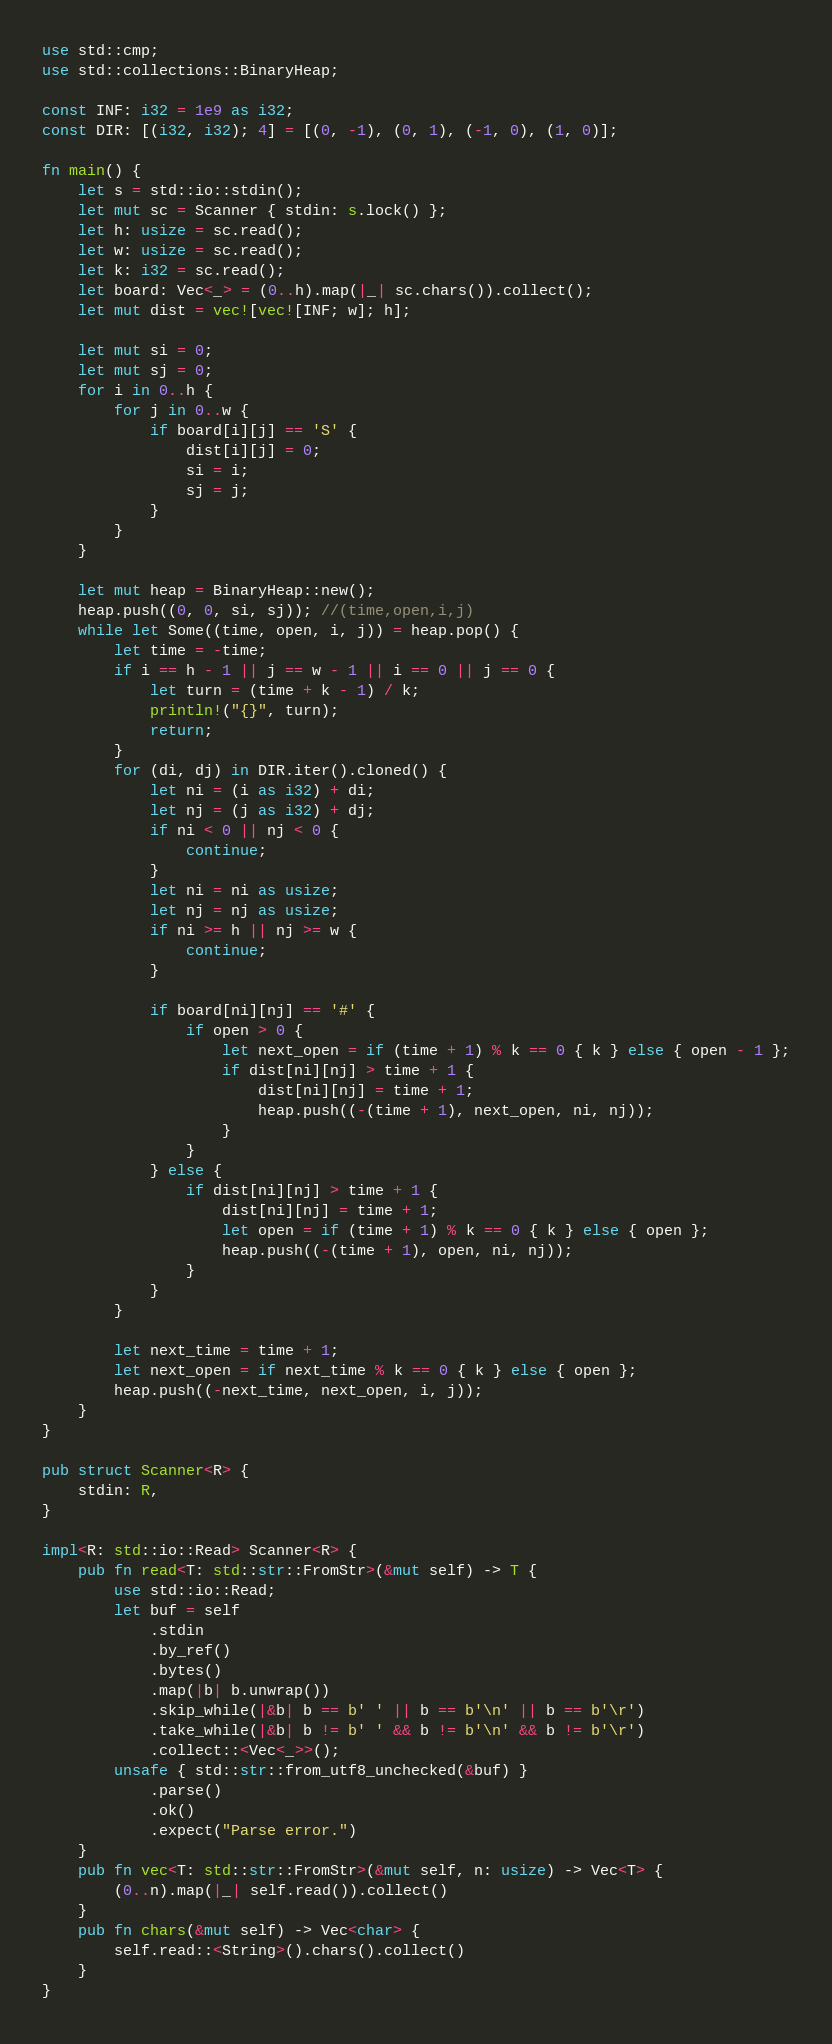Convert code to text. <code><loc_0><loc_0><loc_500><loc_500><_Rust_>use std::cmp;
use std::collections::BinaryHeap;

const INF: i32 = 1e9 as i32;
const DIR: [(i32, i32); 4] = [(0, -1), (0, 1), (-1, 0), (1, 0)];

fn main() {
    let s = std::io::stdin();
    let mut sc = Scanner { stdin: s.lock() };
    let h: usize = sc.read();
    let w: usize = sc.read();
    let k: i32 = sc.read();
    let board: Vec<_> = (0..h).map(|_| sc.chars()).collect();
    let mut dist = vec![vec![INF; w]; h];

    let mut si = 0;
    let mut sj = 0;
    for i in 0..h {
        for j in 0..w {
            if board[i][j] == 'S' {
                dist[i][j] = 0;
                si = i;
                sj = j;
            }
        }
    }

    let mut heap = BinaryHeap::new();
    heap.push((0, 0, si, sj)); //(time,open,i,j)
    while let Some((time, open, i, j)) = heap.pop() {
        let time = -time;
        if i == h - 1 || j == w - 1 || i == 0 || j == 0 {
            let turn = (time + k - 1) / k;
            println!("{}", turn);
            return;
        }
        for (di, dj) in DIR.iter().cloned() {
            let ni = (i as i32) + di;
            let nj = (j as i32) + dj;
            if ni < 0 || nj < 0 {
                continue;
            }
            let ni = ni as usize;
            let nj = nj as usize;
            if ni >= h || nj >= w {
                continue;
            }

            if board[ni][nj] == '#' {
                if open > 0 {
                    let next_open = if (time + 1) % k == 0 { k } else { open - 1 };
                    if dist[ni][nj] > time + 1 {
                        dist[ni][nj] = time + 1;
                        heap.push((-(time + 1), next_open, ni, nj));
                    }
                }
            } else {
                if dist[ni][nj] > time + 1 {
                    dist[ni][nj] = time + 1;
                    let open = if (time + 1) % k == 0 { k } else { open };
                    heap.push((-(time + 1), open, ni, nj));
                }
            }
        }

        let next_time = time + 1;
        let next_open = if next_time % k == 0 { k } else { open };
        heap.push((-next_time, next_open, i, j));
    }
}

pub struct Scanner<R> {
    stdin: R,
}

impl<R: std::io::Read> Scanner<R> {
    pub fn read<T: std::str::FromStr>(&mut self) -> T {
        use std::io::Read;
        let buf = self
            .stdin
            .by_ref()
            .bytes()
            .map(|b| b.unwrap())
            .skip_while(|&b| b == b' ' || b == b'\n' || b == b'\r')
            .take_while(|&b| b != b' ' && b != b'\n' && b != b'\r')
            .collect::<Vec<_>>();
        unsafe { std::str::from_utf8_unchecked(&buf) }
            .parse()
            .ok()
            .expect("Parse error.")
    }
    pub fn vec<T: std::str::FromStr>(&mut self, n: usize) -> Vec<T> {
        (0..n).map(|_| self.read()).collect()
    }
    pub fn chars(&mut self) -> Vec<char> {
        self.read::<String>().chars().collect()
    }
}
</code> 